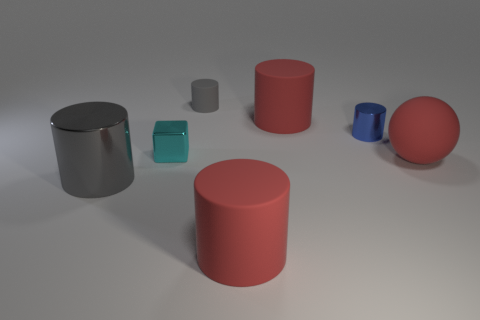Is the color of the small metallic object that is behind the small block the same as the thing that is to the right of the blue metallic cylinder?
Your response must be concise. No. What number of things are either tiny blue objects or large red things?
Your response must be concise. 4. What number of yellow objects have the same material as the small cyan thing?
Offer a very short reply. 0. Is the number of big red cylinders less than the number of large purple shiny blocks?
Make the answer very short. No. Are the red cylinder behind the large gray shiny cylinder and the cyan cube made of the same material?
Provide a succinct answer. No. How many cylinders are tiny gray matte things or cyan metallic things?
Provide a succinct answer. 1. There is a rubber object that is behind the gray metal object and in front of the small cyan metal object; what shape is it?
Your answer should be compact. Sphere. There is a thing on the right side of the metal cylinder on the right side of the metal cylinder that is on the left side of the tiny cyan block; what color is it?
Your answer should be compact. Red. Is the number of large red matte cylinders behind the small gray cylinder less than the number of tiny matte objects?
Your answer should be very brief. Yes. Is the shape of the gray thing on the right side of the large shiny thing the same as the red rubber thing that is in front of the big gray object?
Keep it short and to the point. Yes. 